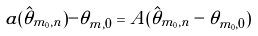Convert formula to latex. <formula><loc_0><loc_0><loc_500><loc_500>a ( \hat { \theta } _ { m _ { 0 } , n } ) - \theta _ { m , 0 } & = A ( \hat { \theta } _ { m _ { 0 } , n } - \theta _ { m _ { 0 } , 0 } )</formula> 